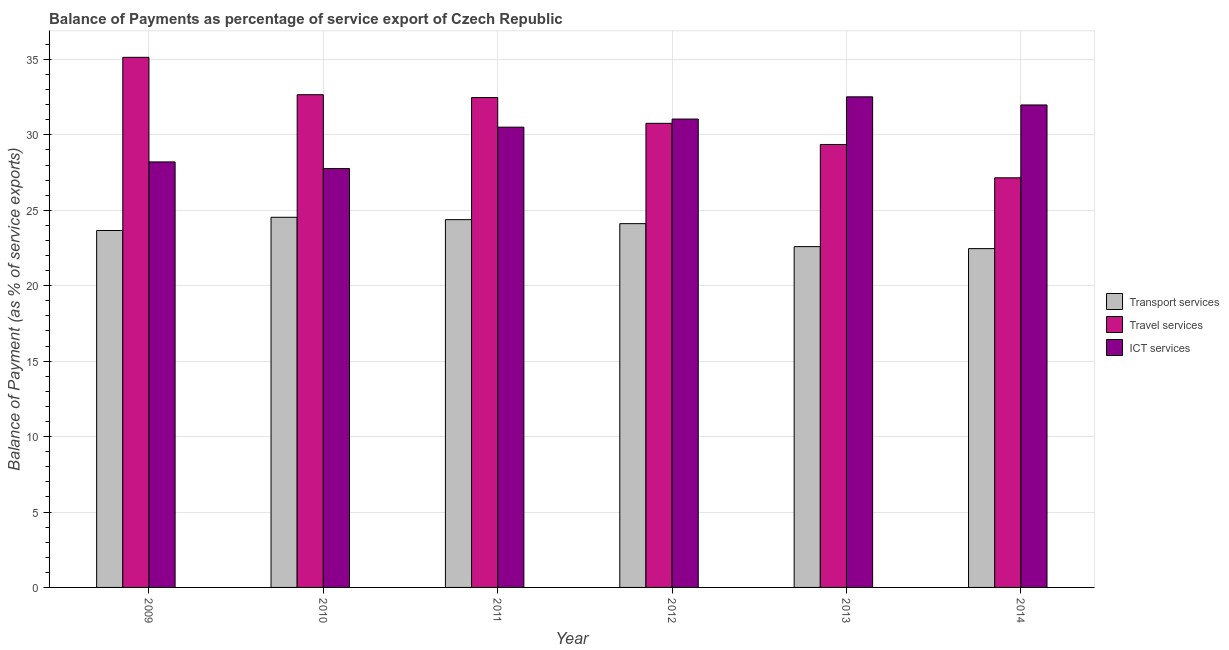How many groups of bars are there?
Keep it short and to the point. 6. Are the number of bars per tick equal to the number of legend labels?
Make the answer very short. Yes. How many bars are there on the 6th tick from the left?
Offer a terse response. 3. What is the label of the 6th group of bars from the left?
Provide a succinct answer. 2014. What is the balance of payment of travel services in 2013?
Ensure brevity in your answer.  29.36. Across all years, what is the maximum balance of payment of ict services?
Give a very brief answer. 32.52. Across all years, what is the minimum balance of payment of ict services?
Make the answer very short. 27.77. What is the total balance of payment of travel services in the graph?
Your response must be concise. 187.56. What is the difference between the balance of payment of ict services in 2013 and that in 2014?
Make the answer very short. 0.54. What is the difference between the balance of payment of travel services in 2012 and the balance of payment of ict services in 2009?
Provide a succinct answer. -4.37. What is the average balance of payment of travel services per year?
Keep it short and to the point. 31.26. In the year 2012, what is the difference between the balance of payment of ict services and balance of payment of travel services?
Provide a succinct answer. 0. In how many years, is the balance of payment of transport services greater than 17 %?
Your response must be concise. 6. What is the ratio of the balance of payment of transport services in 2009 to that in 2010?
Your answer should be very brief. 0.96. Is the difference between the balance of payment of ict services in 2010 and 2013 greater than the difference between the balance of payment of travel services in 2010 and 2013?
Your answer should be compact. No. What is the difference between the highest and the second highest balance of payment of transport services?
Make the answer very short. 0.16. What is the difference between the highest and the lowest balance of payment of transport services?
Keep it short and to the point. 2.08. Is the sum of the balance of payment of travel services in 2009 and 2014 greater than the maximum balance of payment of transport services across all years?
Keep it short and to the point. Yes. What does the 3rd bar from the left in 2014 represents?
Your response must be concise. ICT services. What does the 3rd bar from the right in 2014 represents?
Your response must be concise. Transport services. Are all the bars in the graph horizontal?
Ensure brevity in your answer.  No. How are the legend labels stacked?
Ensure brevity in your answer.  Vertical. What is the title of the graph?
Make the answer very short. Balance of Payments as percentage of service export of Czech Republic. Does "Non-communicable diseases" appear as one of the legend labels in the graph?
Offer a terse response. No. What is the label or title of the X-axis?
Provide a succinct answer. Year. What is the label or title of the Y-axis?
Ensure brevity in your answer.  Balance of Payment (as % of service exports). What is the Balance of Payment (as % of service exports) of Transport services in 2009?
Offer a terse response. 23.66. What is the Balance of Payment (as % of service exports) of Travel services in 2009?
Your answer should be very brief. 35.14. What is the Balance of Payment (as % of service exports) in ICT services in 2009?
Keep it short and to the point. 28.21. What is the Balance of Payment (as % of service exports) in Transport services in 2010?
Ensure brevity in your answer.  24.54. What is the Balance of Payment (as % of service exports) of Travel services in 2010?
Offer a very short reply. 32.66. What is the Balance of Payment (as % of service exports) of ICT services in 2010?
Provide a short and direct response. 27.77. What is the Balance of Payment (as % of service exports) in Transport services in 2011?
Ensure brevity in your answer.  24.38. What is the Balance of Payment (as % of service exports) in Travel services in 2011?
Offer a terse response. 32.47. What is the Balance of Payment (as % of service exports) of ICT services in 2011?
Provide a succinct answer. 30.51. What is the Balance of Payment (as % of service exports) in Transport services in 2012?
Offer a very short reply. 24.12. What is the Balance of Payment (as % of service exports) of Travel services in 2012?
Provide a succinct answer. 30.77. What is the Balance of Payment (as % of service exports) of ICT services in 2012?
Make the answer very short. 31.05. What is the Balance of Payment (as % of service exports) of Transport services in 2013?
Make the answer very short. 22.59. What is the Balance of Payment (as % of service exports) of Travel services in 2013?
Your answer should be very brief. 29.36. What is the Balance of Payment (as % of service exports) of ICT services in 2013?
Make the answer very short. 32.52. What is the Balance of Payment (as % of service exports) in Transport services in 2014?
Ensure brevity in your answer.  22.46. What is the Balance of Payment (as % of service exports) in Travel services in 2014?
Make the answer very short. 27.15. What is the Balance of Payment (as % of service exports) in ICT services in 2014?
Your answer should be compact. 31.98. Across all years, what is the maximum Balance of Payment (as % of service exports) of Transport services?
Keep it short and to the point. 24.54. Across all years, what is the maximum Balance of Payment (as % of service exports) in Travel services?
Give a very brief answer. 35.14. Across all years, what is the maximum Balance of Payment (as % of service exports) in ICT services?
Keep it short and to the point. 32.52. Across all years, what is the minimum Balance of Payment (as % of service exports) in Transport services?
Provide a short and direct response. 22.46. Across all years, what is the minimum Balance of Payment (as % of service exports) of Travel services?
Provide a short and direct response. 27.15. Across all years, what is the minimum Balance of Payment (as % of service exports) of ICT services?
Your response must be concise. 27.77. What is the total Balance of Payment (as % of service exports) of Transport services in the graph?
Your answer should be very brief. 141.74. What is the total Balance of Payment (as % of service exports) of Travel services in the graph?
Ensure brevity in your answer.  187.56. What is the total Balance of Payment (as % of service exports) of ICT services in the graph?
Offer a very short reply. 182.04. What is the difference between the Balance of Payment (as % of service exports) of Transport services in 2009 and that in 2010?
Give a very brief answer. -0.88. What is the difference between the Balance of Payment (as % of service exports) in Travel services in 2009 and that in 2010?
Offer a terse response. 2.48. What is the difference between the Balance of Payment (as % of service exports) of ICT services in 2009 and that in 2010?
Your answer should be very brief. 0.44. What is the difference between the Balance of Payment (as % of service exports) in Transport services in 2009 and that in 2011?
Your answer should be compact. -0.72. What is the difference between the Balance of Payment (as % of service exports) of Travel services in 2009 and that in 2011?
Offer a terse response. 2.67. What is the difference between the Balance of Payment (as % of service exports) of ICT services in 2009 and that in 2011?
Make the answer very short. -2.3. What is the difference between the Balance of Payment (as % of service exports) of Transport services in 2009 and that in 2012?
Your answer should be compact. -0.45. What is the difference between the Balance of Payment (as % of service exports) in Travel services in 2009 and that in 2012?
Offer a terse response. 4.37. What is the difference between the Balance of Payment (as % of service exports) in ICT services in 2009 and that in 2012?
Make the answer very short. -2.84. What is the difference between the Balance of Payment (as % of service exports) in Transport services in 2009 and that in 2013?
Keep it short and to the point. 1.07. What is the difference between the Balance of Payment (as % of service exports) of Travel services in 2009 and that in 2013?
Keep it short and to the point. 5.78. What is the difference between the Balance of Payment (as % of service exports) in ICT services in 2009 and that in 2013?
Your answer should be very brief. -4.31. What is the difference between the Balance of Payment (as % of service exports) in Transport services in 2009 and that in 2014?
Provide a short and direct response. 1.2. What is the difference between the Balance of Payment (as % of service exports) in Travel services in 2009 and that in 2014?
Offer a terse response. 7.99. What is the difference between the Balance of Payment (as % of service exports) in ICT services in 2009 and that in 2014?
Offer a very short reply. -3.78. What is the difference between the Balance of Payment (as % of service exports) of Transport services in 2010 and that in 2011?
Your response must be concise. 0.16. What is the difference between the Balance of Payment (as % of service exports) in Travel services in 2010 and that in 2011?
Offer a terse response. 0.19. What is the difference between the Balance of Payment (as % of service exports) of ICT services in 2010 and that in 2011?
Keep it short and to the point. -2.74. What is the difference between the Balance of Payment (as % of service exports) in Transport services in 2010 and that in 2012?
Ensure brevity in your answer.  0.42. What is the difference between the Balance of Payment (as % of service exports) in Travel services in 2010 and that in 2012?
Ensure brevity in your answer.  1.9. What is the difference between the Balance of Payment (as % of service exports) in ICT services in 2010 and that in 2012?
Make the answer very short. -3.28. What is the difference between the Balance of Payment (as % of service exports) in Transport services in 2010 and that in 2013?
Offer a terse response. 1.94. What is the difference between the Balance of Payment (as % of service exports) in Travel services in 2010 and that in 2013?
Ensure brevity in your answer.  3.3. What is the difference between the Balance of Payment (as % of service exports) in ICT services in 2010 and that in 2013?
Offer a very short reply. -4.75. What is the difference between the Balance of Payment (as % of service exports) in Transport services in 2010 and that in 2014?
Your answer should be compact. 2.08. What is the difference between the Balance of Payment (as % of service exports) of Travel services in 2010 and that in 2014?
Provide a succinct answer. 5.51. What is the difference between the Balance of Payment (as % of service exports) of ICT services in 2010 and that in 2014?
Keep it short and to the point. -4.22. What is the difference between the Balance of Payment (as % of service exports) in Transport services in 2011 and that in 2012?
Keep it short and to the point. 0.27. What is the difference between the Balance of Payment (as % of service exports) of Travel services in 2011 and that in 2012?
Your answer should be compact. 1.71. What is the difference between the Balance of Payment (as % of service exports) in ICT services in 2011 and that in 2012?
Make the answer very short. -0.54. What is the difference between the Balance of Payment (as % of service exports) of Transport services in 2011 and that in 2013?
Keep it short and to the point. 1.79. What is the difference between the Balance of Payment (as % of service exports) of Travel services in 2011 and that in 2013?
Provide a short and direct response. 3.11. What is the difference between the Balance of Payment (as % of service exports) of ICT services in 2011 and that in 2013?
Offer a terse response. -2.01. What is the difference between the Balance of Payment (as % of service exports) of Transport services in 2011 and that in 2014?
Provide a short and direct response. 1.92. What is the difference between the Balance of Payment (as % of service exports) of Travel services in 2011 and that in 2014?
Offer a very short reply. 5.32. What is the difference between the Balance of Payment (as % of service exports) of ICT services in 2011 and that in 2014?
Offer a terse response. -1.47. What is the difference between the Balance of Payment (as % of service exports) in Transport services in 2012 and that in 2013?
Keep it short and to the point. 1.52. What is the difference between the Balance of Payment (as % of service exports) of Travel services in 2012 and that in 2013?
Make the answer very short. 1.4. What is the difference between the Balance of Payment (as % of service exports) of ICT services in 2012 and that in 2013?
Give a very brief answer. -1.47. What is the difference between the Balance of Payment (as % of service exports) of Transport services in 2012 and that in 2014?
Offer a very short reply. 1.66. What is the difference between the Balance of Payment (as % of service exports) in Travel services in 2012 and that in 2014?
Give a very brief answer. 3.61. What is the difference between the Balance of Payment (as % of service exports) of ICT services in 2012 and that in 2014?
Provide a short and direct response. -0.94. What is the difference between the Balance of Payment (as % of service exports) of Transport services in 2013 and that in 2014?
Ensure brevity in your answer.  0.13. What is the difference between the Balance of Payment (as % of service exports) of Travel services in 2013 and that in 2014?
Make the answer very short. 2.21. What is the difference between the Balance of Payment (as % of service exports) of ICT services in 2013 and that in 2014?
Give a very brief answer. 0.54. What is the difference between the Balance of Payment (as % of service exports) of Transport services in 2009 and the Balance of Payment (as % of service exports) of Travel services in 2010?
Your answer should be very brief. -9. What is the difference between the Balance of Payment (as % of service exports) of Transport services in 2009 and the Balance of Payment (as % of service exports) of ICT services in 2010?
Provide a short and direct response. -4.11. What is the difference between the Balance of Payment (as % of service exports) in Travel services in 2009 and the Balance of Payment (as % of service exports) in ICT services in 2010?
Provide a short and direct response. 7.37. What is the difference between the Balance of Payment (as % of service exports) in Transport services in 2009 and the Balance of Payment (as % of service exports) in Travel services in 2011?
Provide a succinct answer. -8.81. What is the difference between the Balance of Payment (as % of service exports) of Transport services in 2009 and the Balance of Payment (as % of service exports) of ICT services in 2011?
Your answer should be compact. -6.85. What is the difference between the Balance of Payment (as % of service exports) in Travel services in 2009 and the Balance of Payment (as % of service exports) in ICT services in 2011?
Provide a short and direct response. 4.63. What is the difference between the Balance of Payment (as % of service exports) in Transport services in 2009 and the Balance of Payment (as % of service exports) in Travel services in 2012?
Your answer should be very brief. -7.11. What is the difference between the Balance of Payment (as % of service exports) of Transport services in 2009 and the Balance of Payment (as % of service exports) of ICT services in 2012?
Provide a succinct answer. -7.39. What is the difference between the Balance of Payment (as % of service exports) of Travel services in 2009 and the Balance of Payment (as % of service exports) of ICT services in 2012?
Keep it short and to the point. 4.09. What is the difference between the Balance of Payment (as % of service exports) in Transport services in 2009 and the Balance of Payment (as % of service exports) in Travel services in 2013?
Provide a succinct answer. -5.7. What is the difference between the Balance of Payment (as % of service exports) of Transport services in 2009 and the Balance of Payment (as % of service exports) of ICT services in 2013?
Keep it short and to the point. -8.86. What is the difference between the Balance of Payment (as % of service exports) in Travel services in 2009 and the Balance of Payment (as % of service exports) in ICT services in 2013?
Your answer should be very brief. 2.62. What is the difference between the Balance of Payment (as % of service exports) of Transport services in 2009 and the Balance of Payment (as % of service exports) of Travel services in 2014?
Your response must be concise. -3.49. What is the difference between the Balance of Payment (as % of service exports) in Transport services in 2009 and the Balance of Payment (as % of service exports) in ICT services in 2014?
Make the answer very short. -8.32. What is the difference between the Balance of Payment (as % of service exports) in Travel services in 2009 and the Balance of Payment (as % of service exports) in ICT services in 2014?
Give a very brief answer. 3.16. What is the difference between the Balance of Payment (as % of service exports) in Transport services in 2010 and the Balance of Payment (as % of service exports) in Travel services in 2011?
Offer a very short reply. -7.94. What is the difference between the Balance of Payment (as % of service exports) of Transport services in 2010 and the Balance of Payment (as % of service exports) of ICT services in 2011?
Keep it short and to the point. -5.97. What is the difference between the Balance of Payment (as % of service exports) of Travel services in 2010 and the Balance of Payment (as % of service exports) of ICT services in 2011?
Your answer should be very brief. 2.15. What is the difference between the Balance of Payment (as % of service exports) in Transport services in 2010 and the Balance of Payment (as % of service exports) in Travel services in 2012?
Provide a short and direct response. -6.23. What is the difference between the Balance of Payment (as % of service exports) of Transport services in 2010 and the Balance of Payment (as % of service exports) of ICT services in 2012?
Your answer should be very brief. -6.51. What is the difference between the Balance of Payment (as % of service exports) in Travel services in 2010 and the Balance of Payment (as % of service exports) in ICT services in 2012?
Make the answer very short. 1.61. What is the difference between the Balance of Payment (as % of service exports) of Transport services in 2010 and the Balance of Payment (as % of service exports) of Travel services in 2013?
Offer a very short reply. -4.83. What is the difference between the Balance of Payment (as % of service exports) in Transport services in 2010 and the Balance of Payment (as % of service exports) in ICT services in 2013?
Make the answer very short. -7.99. What is the difference between the Balance of Payment (as % of service exports) of Travel services in 2010 and the Balance of Payment (as % of service exports) of ICT services in 2013?
Provide a short and direct response. 0.14. What is the difference between the Balance of Payment (as % of service exports) of Transport services in 2010 and the Balance of Payment (as % of service exports) of Travel services in 2014?
Provide a short and direct response. -2.62. What is the difference between the Balance of Payment (as % of service exports) of Transport services in 2010 and the Balance of Payment (as % of service exports) of ICT services in 2014?
Give a very brief answer. -7.45. What is the difference between the Balance of Payment (as % of service exports) of Travel services in 2010 and the Balance of Payment (as % of service exports) of ICT services in 2014?
Your answer should be compact. 0.68. What is the difference between the Balance of Payment (as % of service exports) in Transport services in 2011 and the Balance of Payment (as % of service exports) in Travel services in 2012?
Give a very brief answer. -6.39. What is the difference between the Balance of Payment (as % of service exports) of Transport services in 2011 and the Balance of Payment (as % of service exports) of ICT services in 2012?
Keep it short and to the point. -6.67. What is the difference between the Balance of Payment (as % of service exports) in Travel services in 2011 and the Balance of Payment (as % of service exports) in ICT services in 2012?
Keep it short and to the point. 1.43. What is the difference between the Balance of Payment (as % of service exports) of Transport services in 2011 and the Balance of Payment (as % of service exports) of Travel services in 2013?
Make the answer very short. -4.98. What is the difference between the Balance of Payment (as % of service exports) of Transport services in 2011 and the Balance of Payment (as % of service exports) of ICT services in 2013?
Your answer should be compact. -8.14. What is the difference between the Balance of Payment (as % of service exports) in Travel services in 2011 and the Balance of Payment (as % of service exports) in ICT services in 2013?
Make the answer very short. -0.05. What is the difference between the Balance of Payment (as % of service exports) of Transport services in 2011 and the Balance of Payment (as % of service exports) of Travel services in 2014?
Give a very brief answer. -2.77. What is the difference between the Balance of Payment (as % of service exports) in Transport services in 2011 and the Balance of Payment (as % of service exports) in ICT services in 2014?
Ensure brevity in your answer.  -7.6. What is the difference between the Balance of Payment (as % of service exports) of Travel services in 2011 and the Balance of Payment (as % of service exports) of ICT services in 2014?
Give a very brief answer. 0.49. What is the difference between the Balance of Payment (as % of service exports) in Transport services in 2012 and the Balance of Payment (as % of service exports) in Travel services in 2013?
Your answer should be compact. -5.25. What is the difference between the Balance of Payment (as % of service exports) in Transport services in 2012 and the Balance of Payment (as % of service exports) in ICT services in 2013?
Offer a terse response. -8.41. What is the difference between the Balance of Payment (as % of service exports) in Travel services in 2012 and the Balance of Payment (as % of service exports) in ICT services in 2013?
Your answer should be compact. -1.76. What is the difference between the Balance of Payment (as % of service exports) of Transport services in 2012 and the Balance of Payment (as % of service exports) of Travel services in 2014?
Make the answer very short. -3.04. What is the difference between the Balance of Payment (as % of service exports) in Transport services in 2012 and the Balance of Payment (as % of service exports) in ICT services in 2014?
Give a very brief answer. -7.87. What is the difference between the Balance of Payment (as % of service exports) in Travel services in 2012 and the Balance of Payment (as % of service exports) in ICT services in 2014?
Ensure brevity in your answer.  -1.22. What is the difference between the Balance of Payment (as % of service exports) of Transport services in 2013 and the Balance of Payment (as % of service exports) of Travel services in 2014?
Provide a succinct answer. -4.56. What is the difference between the Balance of Payment (as % of service exports) in Transport services in 2013 and the Balance of Payment (as % of service exports) in ICT services in 2014?
Provide a short and direct response. -9.39. What is the difference between the Balance of Payment (as % of service exports) in Travel services in 2013 and the Balance of Payment (as % of service exports) in ICT services in 2014?
Your response must be concise. -2.62. What is the average Balance of Payment (as % of service exports) of Transport services per year?
Your answer should be very brief. 23.62. What is the average Balance of Payment (as % of service exports) of Travel services per year?
Your response must be concise. 31.26. What is the average Balance of Payment (as % of service exports) in ICT services per year?
Offer a terse response. 30.34. In the year 2009, what is the difference between the Balance of Payment (as % of service exports) of Transport services and Balance of Payment (as % of service exports) of Travel services?
Your answer should be very brief. -11.48. In the year 2009, what is the difference between the Balance of Payment (as % of service exports) of Transport services and Balance of Payment (as % of service exports) of ICT services?
Offer a very short reply. -4.55. In the year 2009, what is the difference between the Balance of Payment (as % of service exports) of Travel services and Balance of Payment (as % of service exports) of ICT services?
Provide a succinct answer. 6.93. In the year 2010, what is the difference between the Balance of Payment (as % of service exports) of Transport services and Balance of Payment (as % of service exports) of Travel services?
Provide a succinct answer. -8.13. In the year 2010, what is the difference between the Balance of Payment (as % of service exports) in Transport services and Balance of Payment (as % of service exports) in ICT services?
Ensure brevity in your answer.  -3.23. In the year 2010, what is the difference between the Balance of Payment (as % of service exports) of Travel services and Balance of Payment (as % of service exports) of ICT services?
Provide a short and direct response. 4.9. In the year 2011, what is the difference between the Balance of Payment (as % of service exports) of Transport services and Balance of Payment (as % of service exports) of Travel services?
Offer a terse response. -8.09. In the year 2011, what is the difference between the Balance of Payment (as % of service exports) of Transport services and Balance of Payment (as % of service exports) of ICT services?
Offer a terse response. -6.13. In the year 2011, what is the difference between the Balance of Payment (as % of service exports) of Travel services and Balance of Payment (as % of service exports) of ICT services?
Your response must be concise. 1.96. In the year 2012, what is the difference between the Balance of Payment (as % of service exports) in Transport services and Balance of Payment (as % of service exports) in Travel services?
Offer a terse response. -6.65. In the year 2012, what is the difference between the Balance of Payment (as % of service exports) in Transport services and Balance of Payment (as % of service exports) in ICT services?
Provide a succinct answer. -6.93. In the year 2012, what is the difference between the Balance of Payment (as % of service exports) of Travel services and Balance of Payment (as % of service exports) of ICT services?
Give a very brief answer. -0.28. In the year 2013, what is the difference between the Balance of Payment (as % of service exports) in Transport services and Balance of Payment (as % of service exports) in Travel services?
Give a very brief answer. -6.77. In the year 2013, what is the difference between the Balance of Payment (as % of service exports) in Transport services and Balance of Payment (as % of service exports) in ICT services?
Your answer should be very brief. -9.93. In the year 2013, what is the difference between the Balance of Payment (as % of service exports) in Travel services and Balance of Payment (as % of service exports) in ICT services?
Give a very brief answer. -3.16. In the year 2014, what is the difference between the Balance of Payment (as % of service exports) in Transport services and Balance of Payment (as % of service exports) in Travel services?
Ensure brevity in your answer.  -4.69. In the year 2014, what is the difference between the Balance of Payment (as % of service exports) of Transport services and Balance of Payment (as % of service exports) of ICT services?
Provide a short and direct response. -9.52. In the year 2014, what is the difference between the Balance of Payment (as % of service exports) in Travel services and Balance of Payment (as % of service exports) in ICT services?
Provide a succinct answer. -4.83. What is the ratio of the Balance of Payment (as % of service exports) of Transport services in 2009 to that in 2010?
Keep it short and to the point. 0.96. What is the ratio of the Balance of Payment (as % of service exports) of Travel services in 2009 to that in 2010?
Ensure brevity in your answer.  1.08. What is the ratio of the Balance of Payment (as % of service exports) of ICT services in 2009 to that in 2010?
Offer a terse response. 1.02. What is the ratio of the Balance of Payment (as % of service exports) of Transport services in 2009 to that in 2011?
Offer a very short reply. 0.97. What is the ratio of the Balance of Payment (as % of service exports) of Travel services in 2009 to that in 2011?
Ensure brevity in your answer.  1.08. What is the ratio of the Balance of Payment (as % of service exports) in ICT services in 2009 to that in 2011?
Provide a short and direct response. 0.92. What is the ratio of the Balance of Payment (as % of service exports) of Transport services in 2009 to that in 2012?
Provide a short and direct response. 0.98. What is the ratio of the Balance of Payment (as % of service exports) of Travel services in 2009 to that in 2012?
Ensure brevity in your answer.  1.14. What is the ratio of the Balance of Payment (as % of service exports) in ICT services in 2009 to that in 2012?
Offer a terse response. 0.91. What is the ratio of the Balance of Payment (as % of service exports) in Transport services in 2009 to that in 2013?
Offer a terse response. 1.05. What is the ratio of the Balance of Payment (as % of service exports) of Travel services in 2009 to that in 2013?
Keep it short and to the point. 1.2. What is the ratio of the Balance of Payment (as % of service exports) of ICT services in 2009 to that in 2013?
Offer a very short reply. 0.87. What is the ratio of the Balance of Payment (as % of service exports) in Transport services in 2009 to that in 2014?
Make the answer very short. 1.05. What is the ratio of the Balance of Payment (as % of service exports) in Travel services in 2009 to that in 2014?
Your answer should be very brief. 1.29. What is the ratio of the Balance of Payment (as % of service exports) in ICT services in 2009 to that in 2014?
Give a very brief answer. 0.88. What is the ratio of the Balance of Payment (as % of service exports) in Transport services in 2010 to that in 2011?
Offer a very short reply. 1.01. What is the ratio of the Balance of Payment (as % of service exports) of ICT services in 2010 to that in 2011?
Keep it short and to the point. 0.91. What is the ratio of the Balance of Payment (as % of service exports) in Transport services in 2010 to that in 2012?
Provide a succinct answer. 1.02. What is the ratio of the Balance of Payment (as % of service exports) of Travel services in 2010 to that in 2012?
Offer a terse response. 1.06. What is the ratio of the Balance of Payment (as % of service exports) in ICT services in 2010 to that in 2012?
Give a very brief answer. 0.89. What is the ratio of the Balance of Payment (as % of service exports) of Transport services in 2010 to that in 2013?
Provide a succinct answer. 1.09. What is the ratio of the Balance of Payment (as % of service exports) in Travel services in 2010 to that in 2013?
Provide a succinct answer. 1.11. What is the ratio of the Balance of Payment (as % of service exports) of ICT services in 2010 to that in 2013?
Your answer should be very brief. 0.85. What is the ratio of the Balance of Payment (as % of service exports) in Transport services in 2010 to that in 2014?
Keep it short and to the point. 1.09. What is the ratio of the Balance of Payment (as % of service exports) in Travel services in 2010 to that in 2014?
Your answer should be very brief. 1.2. What is the ratio of the Balance of Payment (as % of service exports) of ICT services in 2010 to that in 2014?
Offer a terse response. 0.87. What is the ratio of the Balance of Payment (as % of service exports) of Transport services in 2011 to that in 2012?
Your answer should be compact. 1.01. What is the ratio of the Balance of Payment (as % of service exports) in Travel services in 2011 to that in 2012?
Ensure brevity in your answer.  1.06. What is the ratio of the Balance of Payment (as % of service exports) in ICT services in 2011 to that in 2012?
Offer a terse response. 0.98. What is the ratio of the Balance of Payment (as % of service exports) in Transport services in 2011 to that in 2013?
Your response must be concise. 1.08. What is the ratio of the Balance of Payment (as % of service exports) in Travel services in 2011 to that in 2013?
Your answer should be very brief. 1.11. What is the ratio of the Balance of Payment (as % of service exports) of ICT services in 2011 to that in 2013?
Your answer should be compact. 0.94. What is the ratio of the Balance of Payment (as % of service exports) in Transport services in 2011 to that in 2014?
Provide a short and direct response. 1.09. What is the ratio of the Balance of Payment (as % of service exports) of Travel services in 2011 to that in 2014?
Offer a terse response. 1.2. What is the ratio of the Balance of Payment (as % of service exports) in ICT services in 2011 to that in 2014?
Your answer should be very brief. 0.95. What is the ratio of the Balance of Payment (as % of service exports) of Transport services in 2012 to that in 2013?
Offer a very short reply. 1.07. What is the ratio of the Balance of Payment (as % of service exports) in Travel services in 2012 to that in 2013?
Provide a succinct answer. 1.05. What is the ratio of the Balance of Payment (as % of service exports) of ICT services in 2012 to that in 2013?
Keep it short and to the point. 0.95. What is the ratio of the Balance of Payment (as % of service exports) in Transport services in 2012 to that in 2014?
Give a very brief answer. 1.07. What is the ratio of the Balance of Payment (as % of service exports) in Travel services in 2012 to that in 2014?
Provide a short and direct response. 1.13. What is the ratio of the Balance of Payment (as % of service exports) in ICT services in 2012 to that in 2014?
Provide a succinct answer. 0.97. What is the ratio of the Balance of Payment (as % of service exports) of Transport services in 2013 to that in 2014?
Keep it short and to the point. 1.01. What is the ratio of the Balance of Payment (as % of service exports) in Travel services in 2013 to that in 2014?
Provide a succinct answer. 1.08. What is the ratio of the Balance of Payment (as % of service exports) in ICT services in 2013 to that in 2014?
Keep it short and to the point. 1.02. What is the difference between the highest and the second highest Balance of Payment (as % of service exports) of Transport services?
Give a very brief answer. 0.16. What is the difference between the highest and the second highest Balance of Payment (as % of service exports) in Travel services?
Offer a terse response. 2.48. What is the difference between the highest and the second highest Balance of Payment (as % of service exports) of ICT services?
Make the answer very short. 0.54. What is the difference between the highest and the lowest Balance of Payment (as % of service exports) in Transport services?
Your answer should be compact. 2.08. What is the difference between the highest and the lowest Balance of Payment (as % of service exports) of Travel services?
Offer a terse response. 7.99. What is the difference between the highest and the lowest Balance of Payment (as % of service exports) in ICT services?
Ensure brevity in your answer.  4.75. 